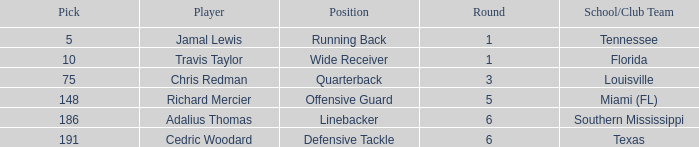Where's the first round that southern mississippi shows up during the draft? 6.0. 